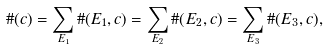<formula> <loc_0><loc_0><loc_500><loc_500>\# ( c ) = \sum _ { E _ { 1 } } \# ( E _ { 1 } , c ) = \sum _ { E _ { 2 } } \# ( E _ { 2 } , c ) = \sum _ { E _ { 3 } } \# ( E _ { 3 } , c ) ,</formula> 